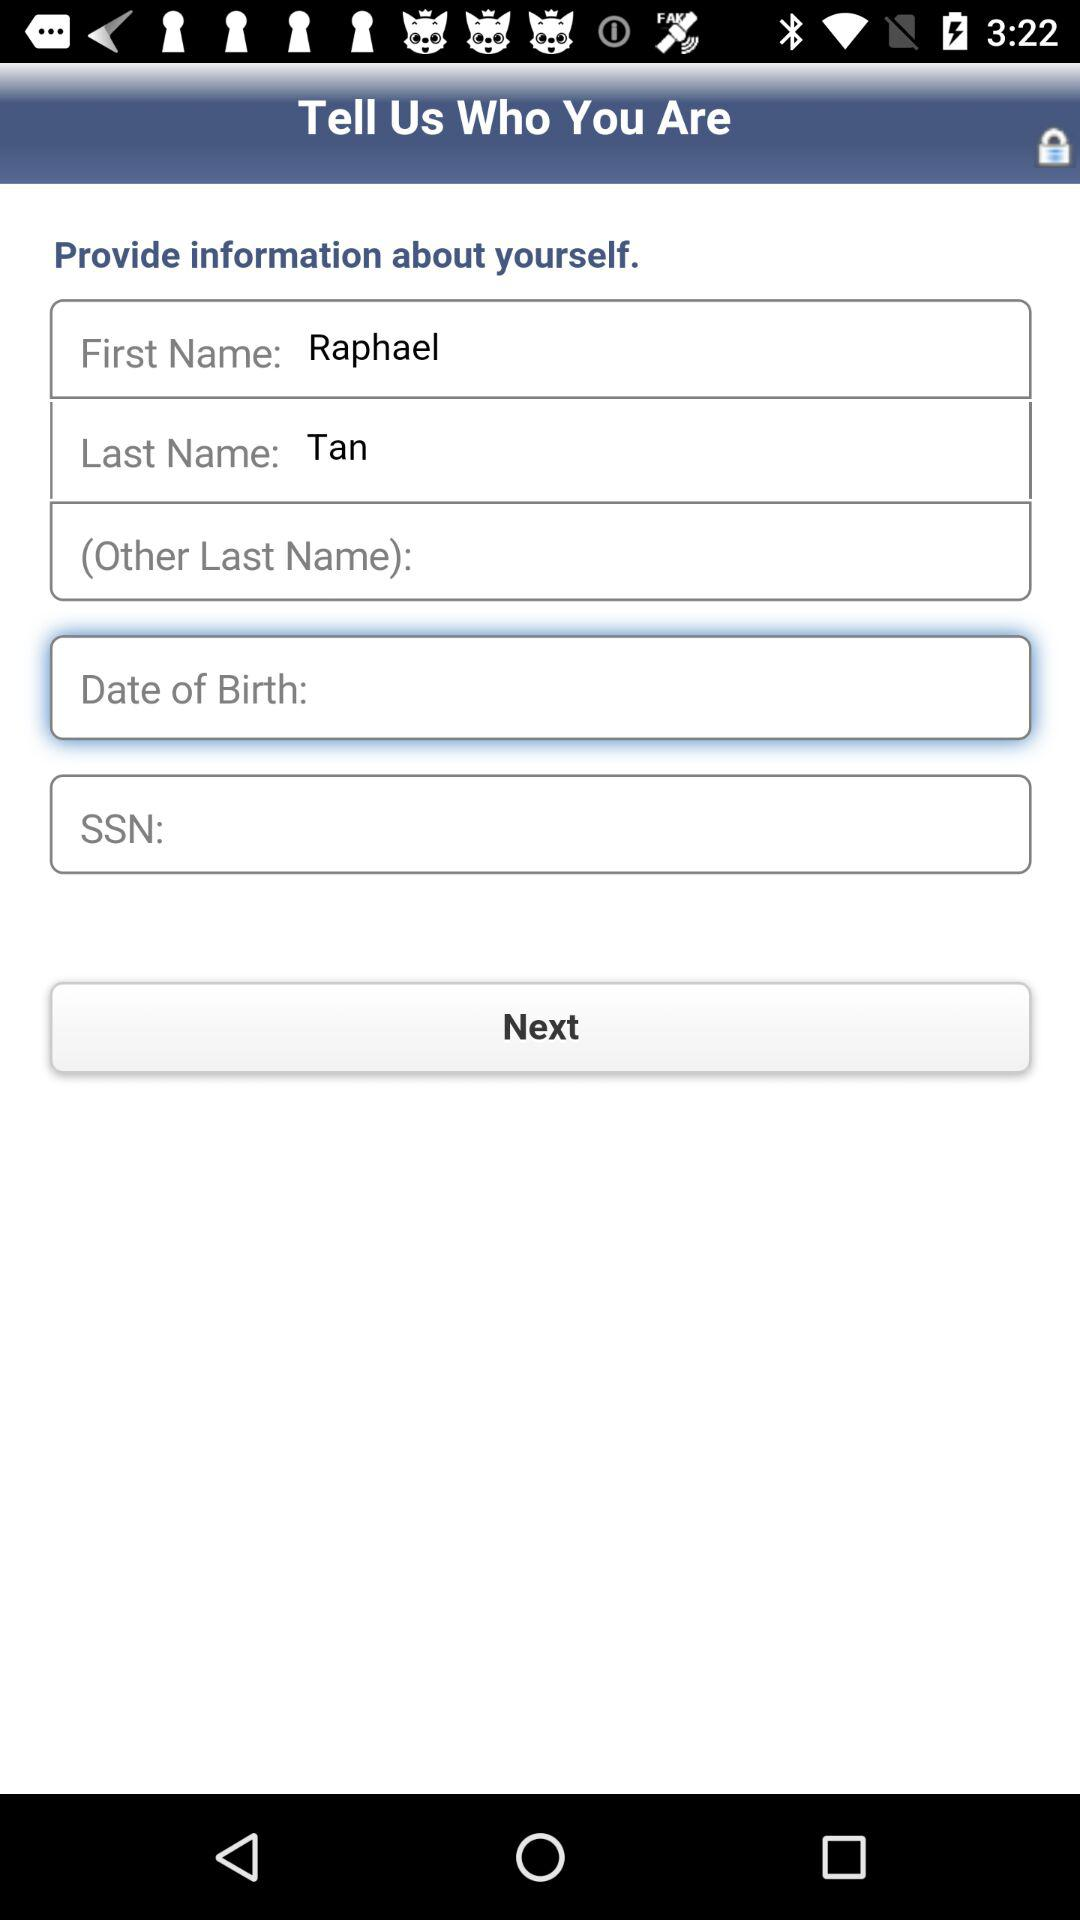What's the first name? The first name is Raphael. 